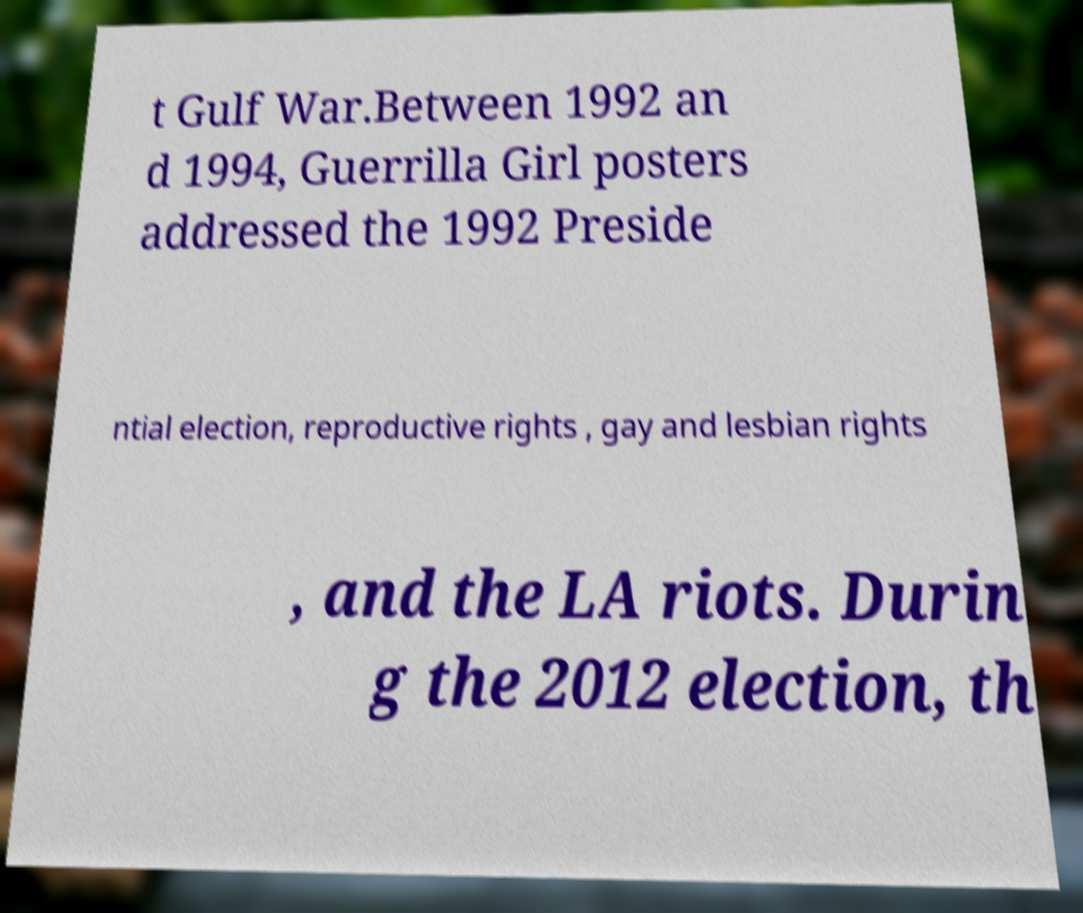Could you assist in decoding the text presented in this image and type it out clearly? t Gulf War.Between 1992 an d 1994, Guerrilla Girl posters addressed the 1992 Preside ntial election, reproductive rights , gay and lesbian rights , and the LA riots. Durin g the 2012 election, th 